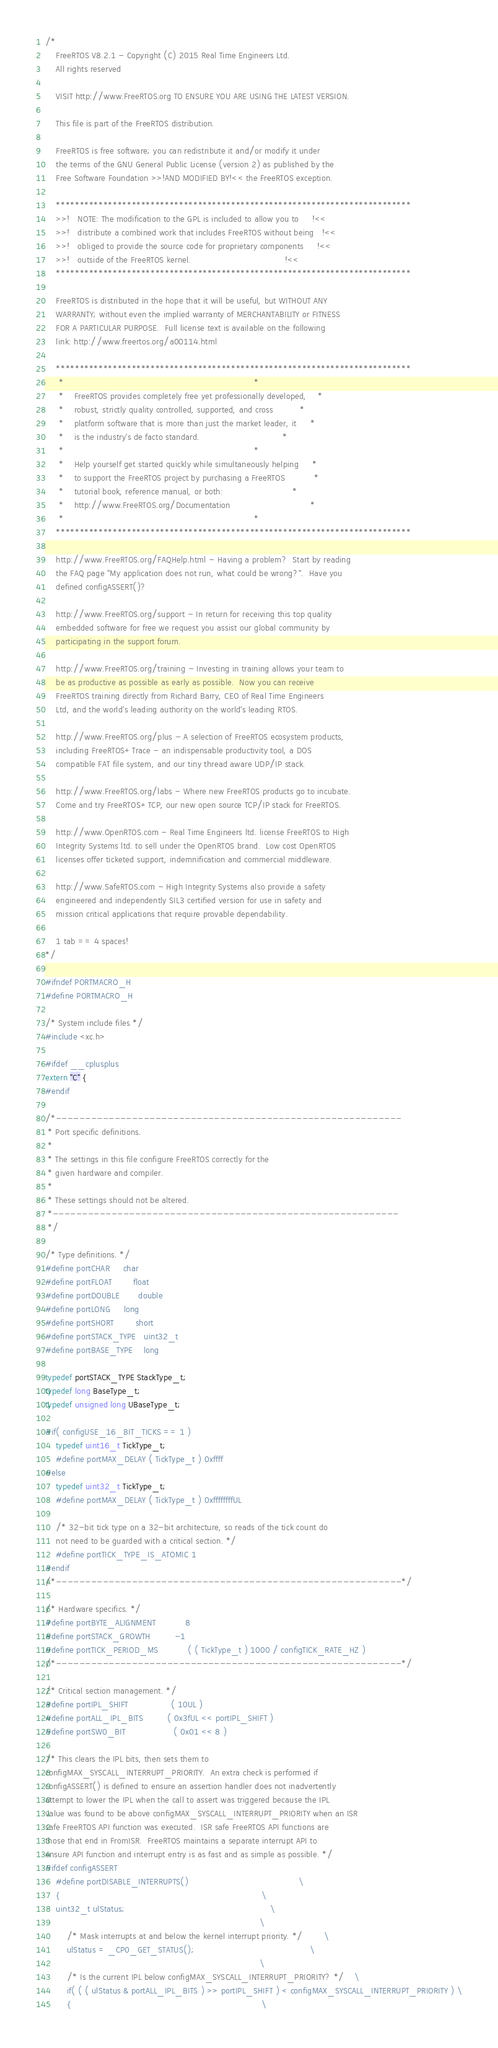<code> <loc_0><loc_0><loc_500><loc_500><_C_>/*
    FreeRTOS V8.2.1 - Copyright (C) 2015 Real Time Engineers Ltd.
    All rights reserved

    VISIT http://www.FreeRTOS.org TO ENSURE YOU ARE USING THE LATEST VERSION.

    This file is part of the FreeRTOS distribution.

    FreeRTOS is free software; you can redistribute it and/or modify it under
    the terms of the GNU General Public License (version 2) as published by the
    Free Software Foundation >>!AND MODIFIED BY!<< the FreeRTOS exception.

    ***************************************************************************
    >>!   NOTE: The modification to the GPL is included to allow you to     !<<
    >>!   distribute a combined work that includes FreeRTOS without being   !<<
    >>!   obliged to provide the source code for proprietary components     !<<
    >>!   outside of the FreeRTOS kernel.                                   !<<
    ***************************************************************************

    FreeRTOS is distributed in the hope that it will be useful, but WITHOUT ANY
    WARRANTY; without even the implied warranty of MERCHANTABILITY or FITNESS
    FOR A PARTICULAR PURPOSE.  Full license text is available on the following
    link: http://www.freertos.org/a00114.html

    ***************************************************************************
     *                                                                       *
     *    FreeRTOS provides completely free yet professionally developed,    *
     *    robust, strictly quality controlled, supported, and cross          *
     *    platform software that is more than just the market leader, it     *
     *    is the industry's de facto standard.                               *
     *                                                                       *
     *    Help yourself get started quickly while simultaneously helping     *
     *    to support the FreeRTOS project by purchasing a FreeRTOS           *
     *    tutorial book, reference manual, or both:                          *
     *    http://www.FreeRTOS.org/Documentation                              *
     *                                                                       *
    ***************************************************************************

    http://www.FreeRTOS.org/FAQHelp.html - Having a problem?  Start by reading
    the FAQ page "My application does not run, what could be wrong?".  Have you
    defined configASSERT()?

    http://www.FreeRTOS.org/support - In return for receiving this top quality
    embedded software for free we request you assist our global community by
    participating in the support forum.

    http://www.FreeRTOS.org/training - Investing in training allows your team to
    be as productive as possible as early as possible.  Now you can receive
    FreeRTOS training directly from Richard Barry, CEO of Real Time Engineers
    Ltd, and the world's leading authority on the world's leading RTOS.

    http://www.FreeRTOS.org/plus - A selection of FreeRTOS ecosystem products,
    including FreeRTOS+Trace - an indispensable productivity tool, a DOS
    compatible FAT file system, and our tiny thread aware UDP/IP stack.

    http://www.FreeRTOS.org/labs - Where new FreeRTOS products go to incubate.
    Come and try FreeRTOS+TCP, our new open source TCP/IP stack for FreeRTOS.

    http://www.OpenRTOS.com - Real Time Engineers ltd. license FreeRTOS to High
    Integrity Systems ltd. to sell under the OpenRTOS brand.  Low cost OpenRTOS
    licenses offer ticketed support, indemnification and commercial middleware.

    http://www.SafeRTOS.com - High Integrity Systems also provide a safety
    engineered and independently SIL3 certified version for use in safety and
    mission critical applications that require provable dependability.

    1 tab == 4 spaces!
*/

#ifndef PORTMACRO_H
#define PORTMACRO_H

/* System include files */
#include <xc.h>

#ifdef __cplusplus
extern "C" {
#endif

/*-----------------------------------------------------------
 * Port specific definitions.
 *
 * The settings in this file configure FreeRTOS correctly for the
 * given hardware and compiler.
 *
 * These settings should not be altered.
 *-----------------------------------------------------------
 */

/* Type definitions. */
#define portCHAR		char
#define portFLOAT		float
#define portDOUBLE		double
#define portLONG		long
#define portSHORT		short
#define portSTACK_TYPE	uint32_t
#define portBASE_TYPE	long

typedef portSTACK_TYPE StackType_t;
typedef long BaseType_t;
typedef unsigned long UBaseType_t;

#if( configUSE_16_BIT_TICKS == 1 )
	typedef uint16_t TickType_t;
	#define portMAX_DELAY ( TickType_t ) 0xffff
#else
	typedef uint32_t TickType_t;
	#define portMAX_DELAY ( TickType_t ) 0xffffffffUL

	/* 32-bit tick type on a 32-bit architecture, so reads of the tick count do
	not need to be guarded with a critical section. */
	#define portTICK_TYPE_IS_ATOMIC 1
#endif
/*-----------------------------------------------------------*/

/* Hardware specifics. */
#define portBYTE_ALIGNMENT			8
#define portSTACK_GROWTH			-1
#define portTICK_PERIOD_MS			( ( TickType_t ) 1000 / configTICK_RATE_HZ )
/*-----------------------------------------------------------*/

/* Critical section management. */
#define portIPL_SHIFT				( 10UL )
#define portALL_IPL_BITS			( 0x3fUL << portIPL_SHIFT )
#define portSW0_BIT					( 0x01 << 8 )

/* This clears the IPL bits, then sets them to
configMAX_SYSCALL_INTERRUPT_PRIORITY.  An extra check is performed if
configASSERT() is defined to ensure an assertion handler does not inadvertently
attempt to lower the IPL when the call to assert was triggered because the IPL
value was found to be above configMAX_SYSCALL_INTERRUPT_PRIORITY when an ISR
safe FreeRTOS API function was executed.  ISR safe FreeRTOS API functions are
those that end in FromISR.  FreeRTOS maintains a separate interrupt API to
ensure API function and interrupt entry is as fast and as simple as possible. */
#ifdef configASSERT
	#define portDISABLE_INTERRUPTS()											\
	{																			\
	uint32_t ulStatus;														\
																				\
		/* Mask interrupts at and below the kernel interrupt priority. */		\
		ulStatus = _CP0_GET_STATUS();											\
																				\
		/* Is the current IPL below configMAX_SYSCALL_INTERRUPT_PRIORITY? */	\
		if( ( ( ulStatus & portALL_IPL_BITS ) >> portIPL_SHIFT ) < configMAX_SYSCALL_INTERRUPT_PRIORITY ) \
		{																		\</code> 